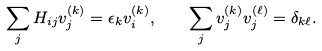Convert formula to latex. <formula><loc_0><loc_0><loc_500><loc_500>\sum _ { j } H _ { i j } v _ { j } ^ { ( k ) } = \epsilon _ { k } v _ { i } ^ { ( k ) } , \quad \sum _ { j } v _ { j } ^ { ( k ) } v _ { j } ^ { ( \ell ) } = \delta _ { k \ell } .</formula> 